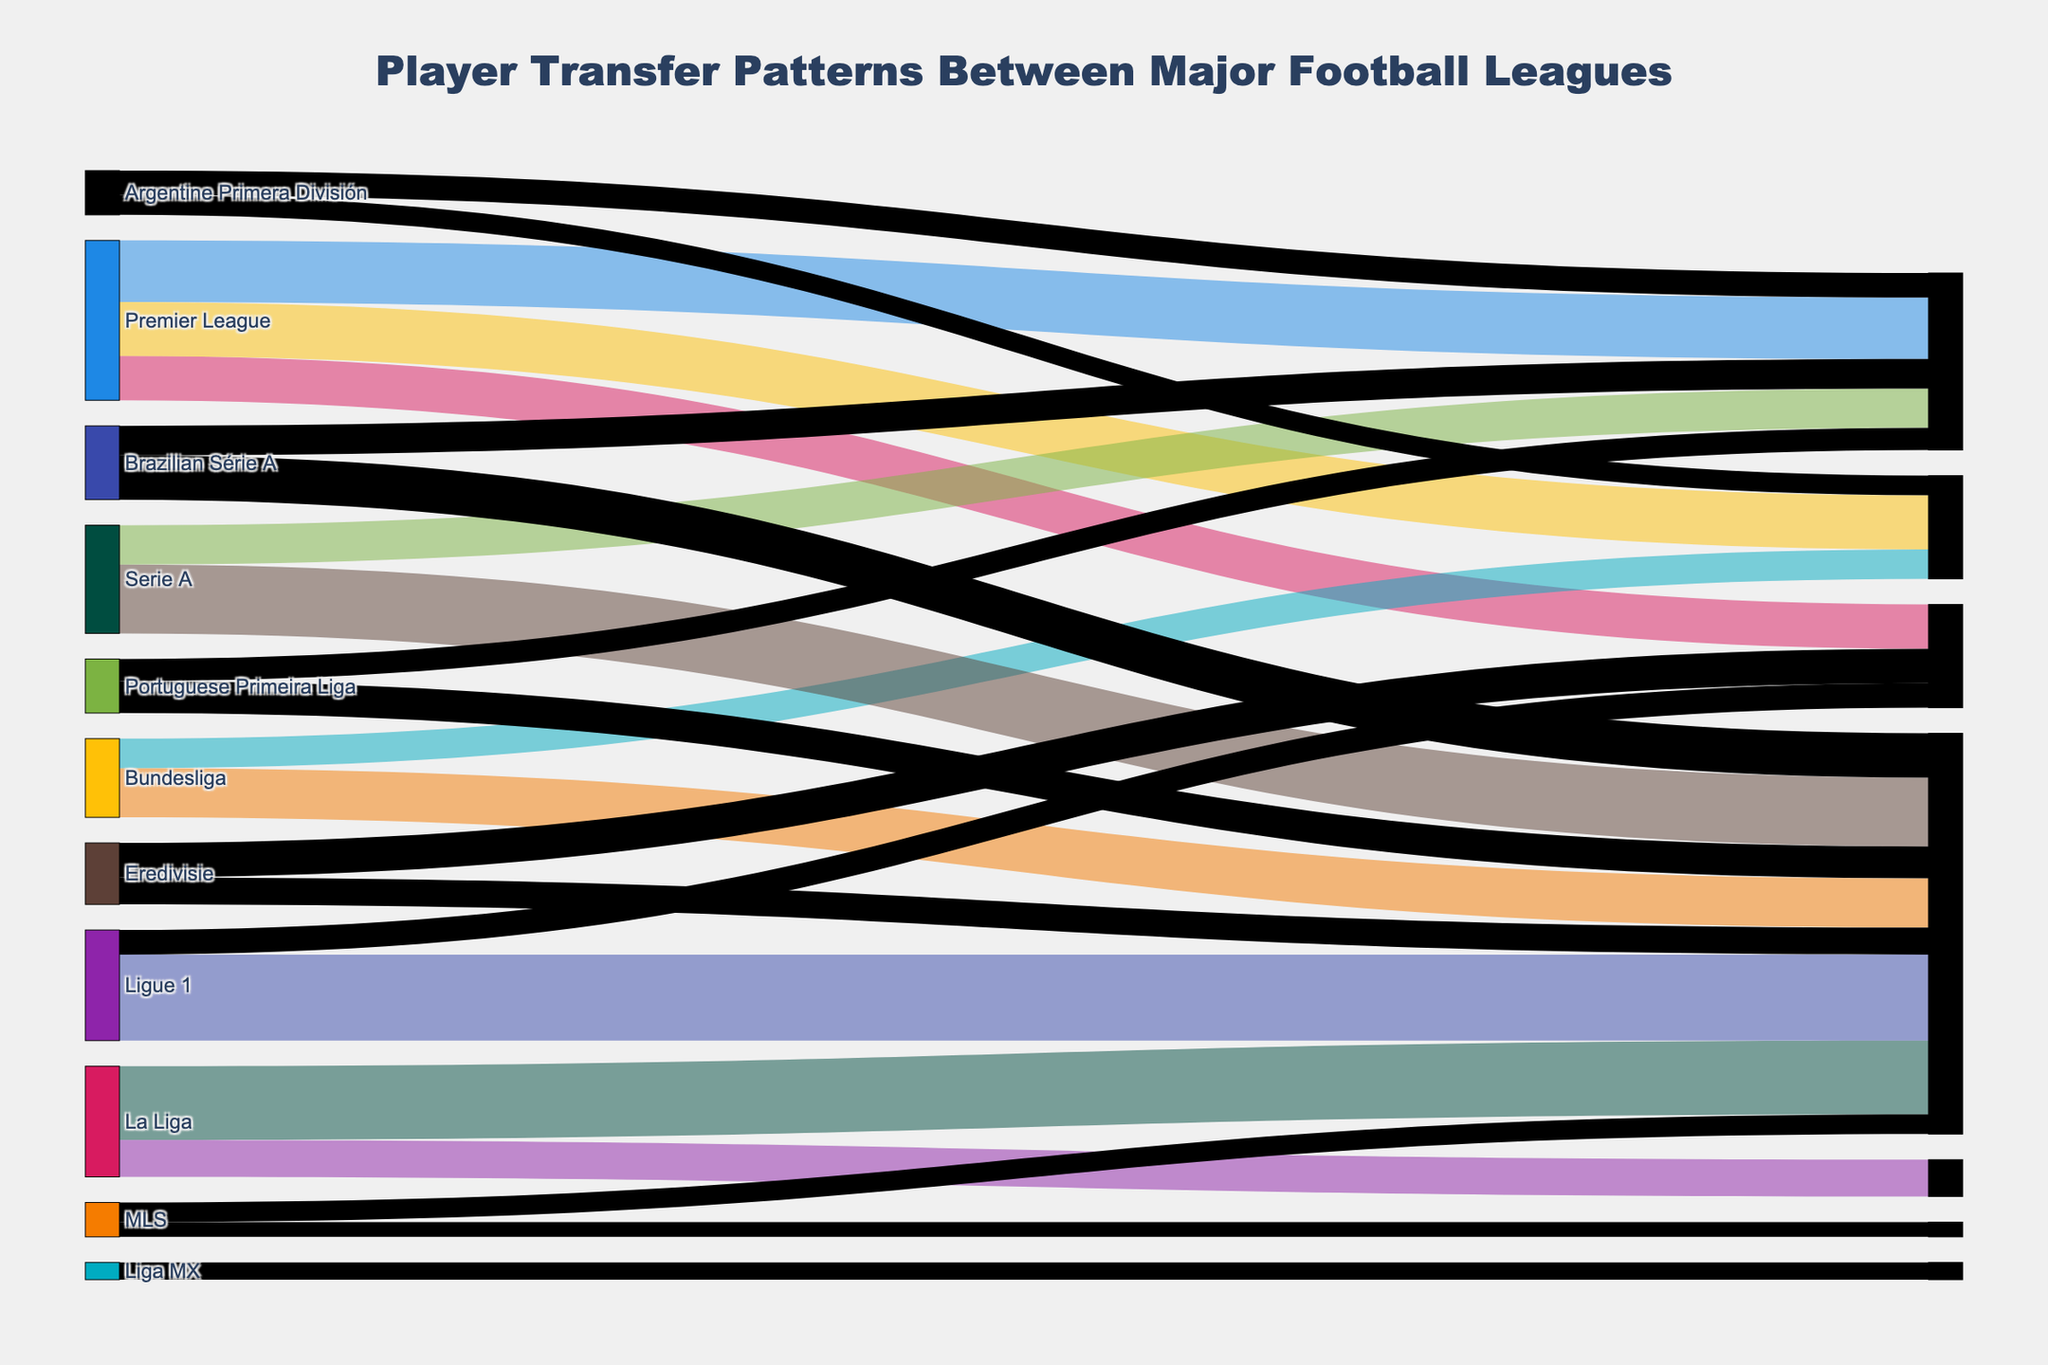What is the title of the Sankey diagram? The title of the diagram is usually written at the top of the figure. It provides a summary of what the figure is about.
Answer: "Player Transfer Patterns Between Major Football Leagues" Which league has the most outgoing transfers to the Premier League? To determine this, look for the widest link pointing from another league to the Premier League. The width of the link represents the number of transfers.
Answer: Ligue 1 How many player transfers are there from the Premier League to Serie A? Identify the link that connects the Premier League to Serie A and check the value associated with it.
Answer: 22 What is the total number of player transfers to the Premier League? Add up all the values of the links that end at the Premier League.
Answer: 150 Which leagues have outgoing transfers to the La Liga and what are their respective transfer values? Look for all links that have La Liga as the target and note the source and their associated values.
Answer: Premier League (25), Serie A (16), Portuguese Primeira Liga (9), Brazilian Série A (12), Argentine Primera División (10) How many more transfers are there from La Liga to the Premier League than from the Bundesliga to the Premier League? Subtract the transfers from Bundesliga to the Premier League from those from La Liga to the Premier League.
Answer: 10 Which league has more transfers to Serie A, the Bundesliga or the Argentine Primera División? Compare the values of transfers from both leagues into Serie A.
Answer: Bundesliga What is the most common destination league for players leaving the Premier League? Look for the widest link originating from the Premier League and identify its target league.
Answer: La Liga What is the least common league for player transfers from the MLS to other leagues? Compare the values of the two outgoing links from the MLS and identify the one with the smaller value.
Answer: Liga MX Which leagues contribute transfers to both the Premier League and La Liga? Identify leagues that have links going to both the Premier League and La Liga.
Answer: Brazilian Série A, Portuguese Primeira Liga 